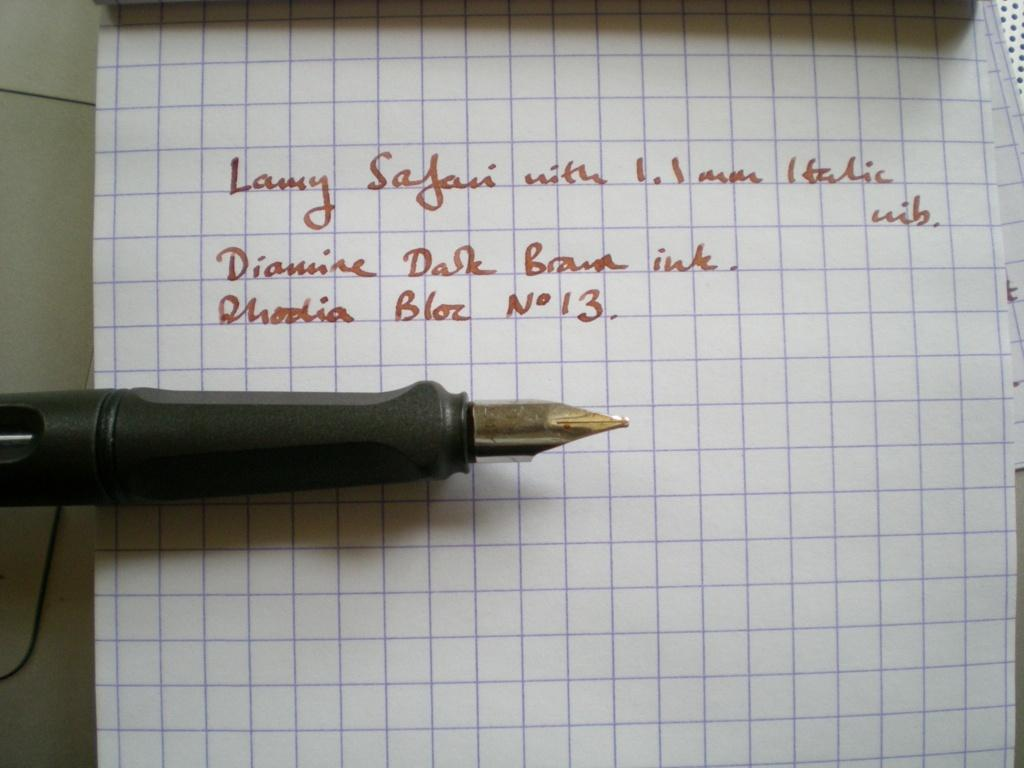What is written on the paper in the image? There is text on a paper in the image. What can be used to write on the paper? There is a pen visible in the image. How does the beggar interact with the text on the paper in the image? There is no beggar present in the image, so it is not possible to answer that question. 